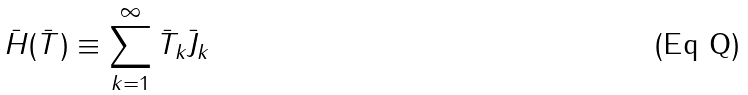<formula> <loc_0><loc_0><loc_500><loc_500>\bar { H } ( \bar { T } ) \equiv \sum _ { k = 1 } ^ { \infty } \bar { T } _ { k } \bar { J } _ { k }</formula> 